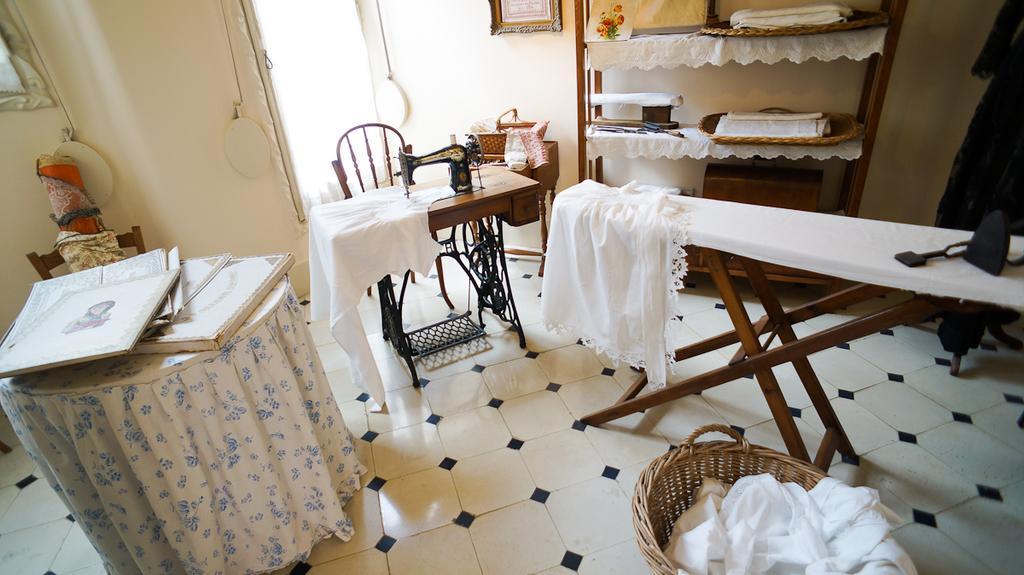Could you give a brief overview of what you see in this image? This is the picture of a room. On the right side of the image there is a table and there is a iron box and cloth on the table. There are clothes in the basket. There are clothes and there is a basket in the cupboard. In the middle of the image there is a sewing machine and there is a chair and there is a basket on the table. On the left side of the image there are boxes on the table and the table is covered with the floral cloth and there is a bag on the chair. At the back there is a curtain and there are frames on the wall. 